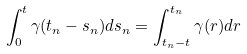<formula> <loc_0><loc_0><loc_500><loc_500>\int _ { 0 } ^ { t } \gamma ( t _ { n } - s _ { n } ) d s _ { n } & = \int _ { t _ { n } - t } ^ { t _ { n } } \gamma ( r ) d r</formula> 